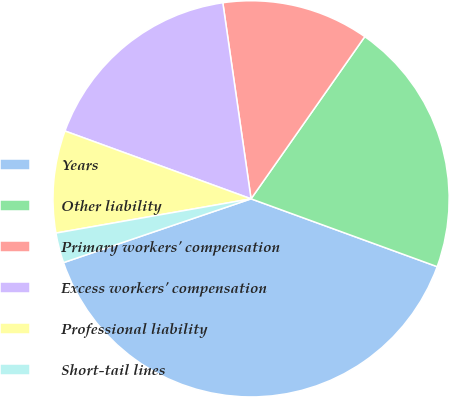Convert chart to OTSL. <chart><loc_0><loc_0><loc_500><loc_500><pie_chart><fcel>Years<fcel>Other liability<fcel>Primary workers' compensation<fcel>Excess workers' compensation<fcel>Professional liability<fcel>Short-tail lines<nl><fcel>39.22%<fcel>20.83%<fcel>12.01%<fcel>17.16%<fcel>8.33%<fcel>2.45%<nl></chart> 